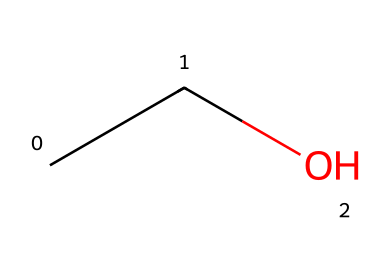What is the molecular formula of this compound? The SMILES representation "CCO" indicates two carbon atoms (C), along with five hydrogen atoms (H) and one oxygen atom (O) based on standard bonding rules for aliphatic compounds, leading to a molecular formula of C2H6O.
Answer: C2H6O How many carbon atoms are present in this structure? The SMILES "CCO" shows two "C" characters in a row, indicating that there are two carbon atoms in the compound.
Answer: 2 What functional group is present in ethanol? Ethanol's structure contains a functional group characterized by a hydroxyl group (-OH) indicated by the 'O' in the SMILES notation, which defines it as an alcohol.
Answer: alcohol Is ethanol a saturated or unsaturated compound? The presence of single bonds only, as seen from the SMILES structure "CCO," suggests that ethanol is saturated, meaning it contains no carbon-carbon double or triple bonds.
Answer: saturated What is the degree of saturation of this compound? Degrees of saturation determine the number of double bonds in the structure. Since ethanol "CCO" has only single bonds between the carbons and no cycles, it has a degree of saturation of zero.
Answer: zero What type of aliphatic compound is ethanol classified as? Ethanol, based on its structure and functional group, is classified as a primary alcohol because the hydroxyl group is attached to a carbon that is only connected to one other carbon.
Answer: primary alcohol 